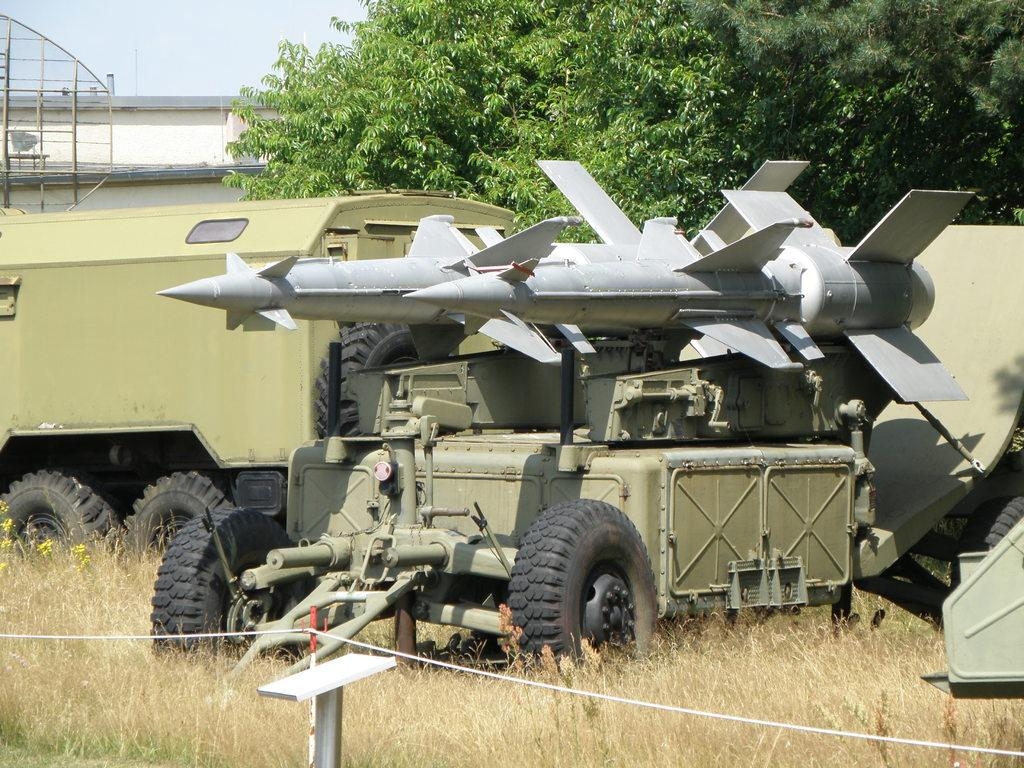What type of vegetation is present in the image? There is dry grass in the image. What else can be seen in the image besides the dry grass? There are vehicles, stairs, a building, trees, and the sky visible in the image. Can you describe the vehicles in the image? Unfortunately, the facts provided do not give specific details about the vehicles. What is the color of the sky in the image? The color of the sky is not mentioned in the provided facts. What type of copper vase can be seen on the stairs in the image? There is no copper vase present in the image. Are the shoes of the people in the image visible? The facts provided do not mention any people or shoes in the image. 